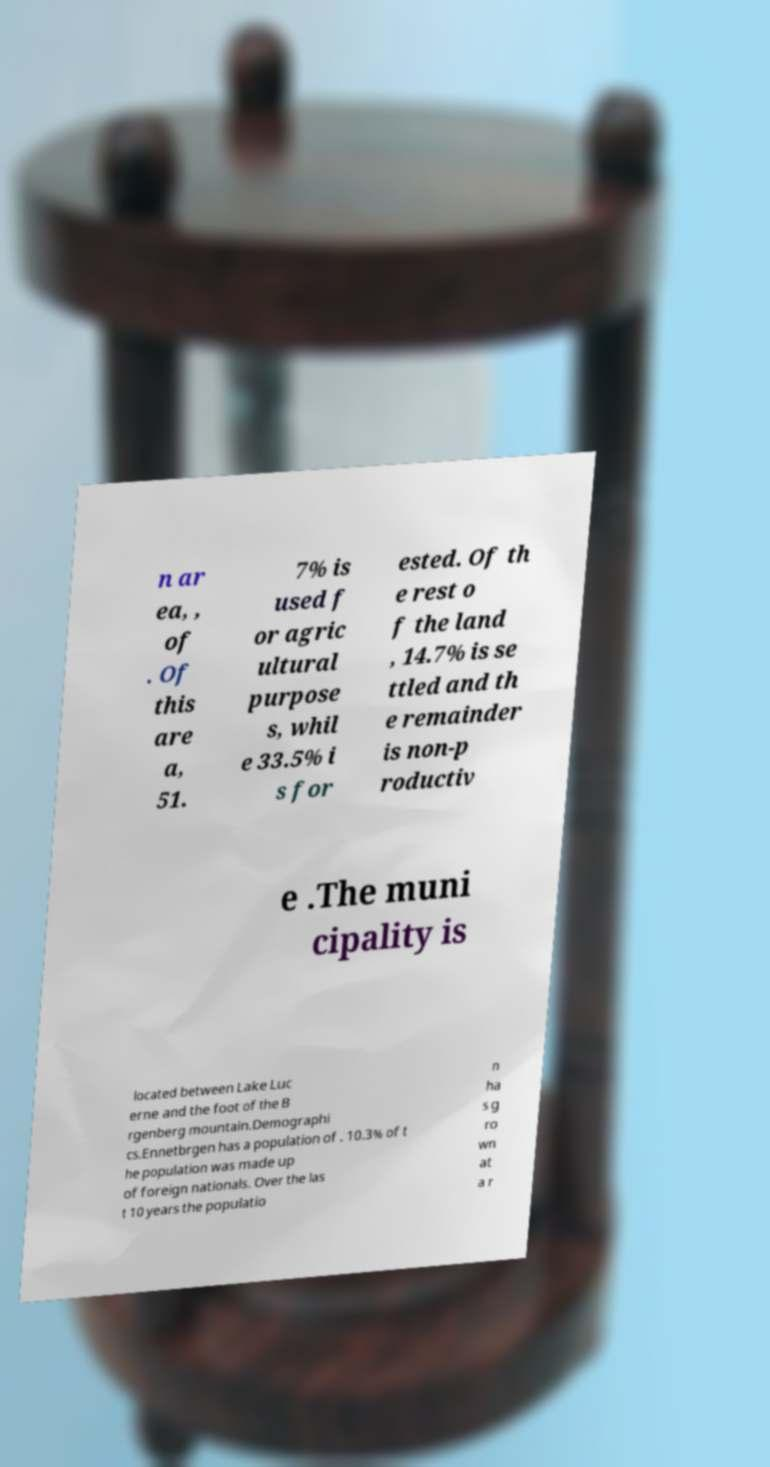Can you read and provide the text displayed in the image?This photo seems to have some interesting text. Can you extract and type it out for me? n ar ea, , of . Of this are a, 51. 7% is used f or agric ultural purpose s, whil e 33.5% i s for ested. Of th e rest o f the land , 14.7% is se ttled and th e remainder is non-p roductiv e .The muni cipality is located between Lake Luc erne and the foot of the B rgenberg mountain.Demographi cs.Ennetbrgen has a population of . 10.3% of t he population was made up of foreign nationals. Over the las t 10 years the populatio n ha s g ro wn at a r 